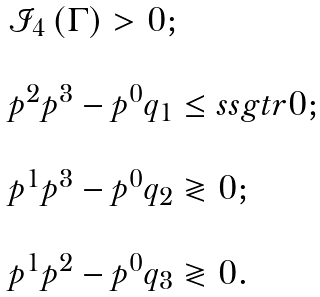Convert formula to latex. <formula><loc_0><loc_0><loc_500><loc_500>\begin{array} { l } \mathcal { I } _ { 4 } \left ( \Gamma \right ) > 0 ; \\ \\ p ^ { 2 } p ^ { 3 } - p ^ { 0 } q _ { 1 } \leq s s g t r 0 ; \\ \\ p ^ { 1 } p ^ { 3 } - p ^ { 0 } q _ { 2 } \gtrless 0 ; \\ \\ p ^ { 1 } p ^ { 2 } - p ^ { 0 } q _ { 3 } \gtrless 0 . \end{array}</formula> 